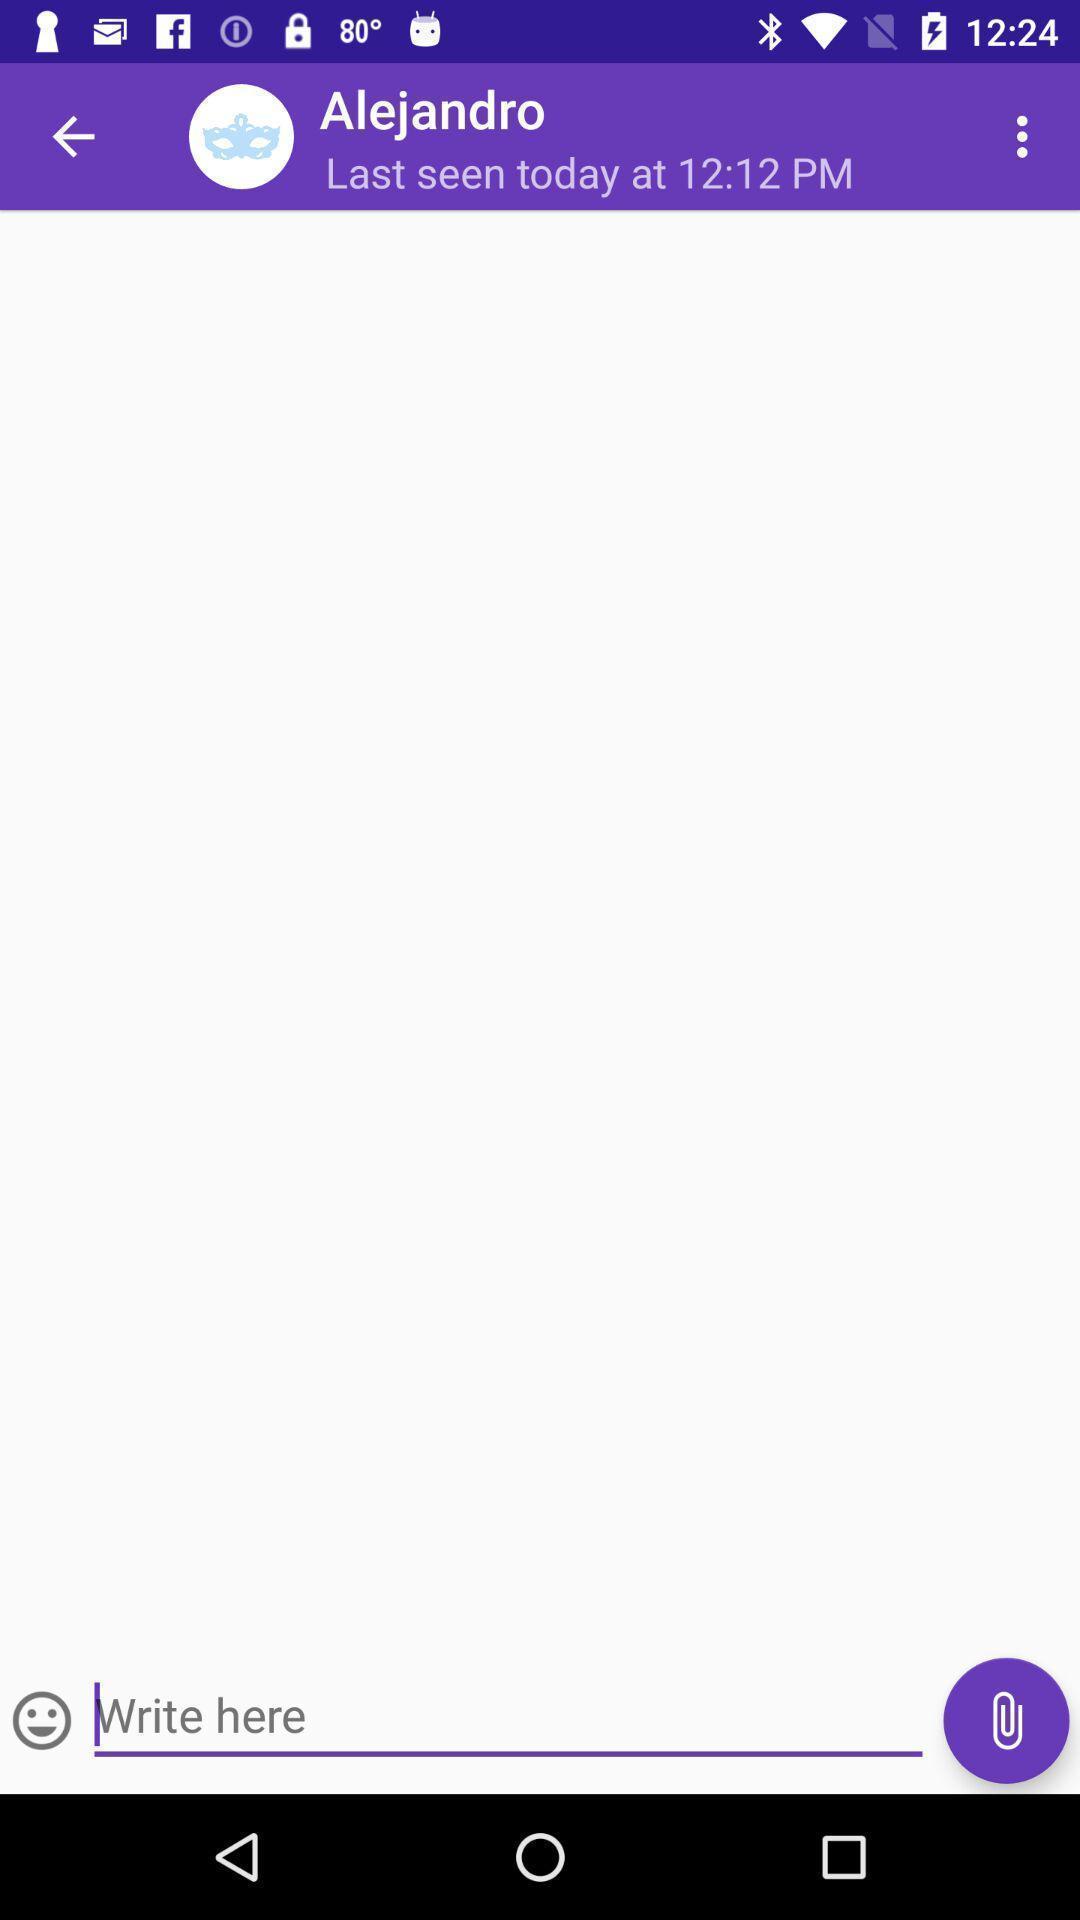Describe the content in this image. Screen showing the chat page of social app. 